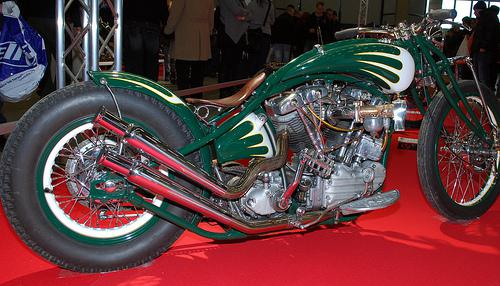Question: where was this photo taken?
Choices:
A. At a concert.
B. At a bike show.
C. In a church.
D. At my house.
Answer with the letter. Answer: B Question: what color is the carpet?
Choices:
A. White.
B. Brown.
C. Red.
D. Blue.
Answer with the letter. Answer: C Question: what is present?
Choices:
A. A car.
B. A truck.
C. A motorcycle.
D. A bike.
Answer with the letter. Answer: D 